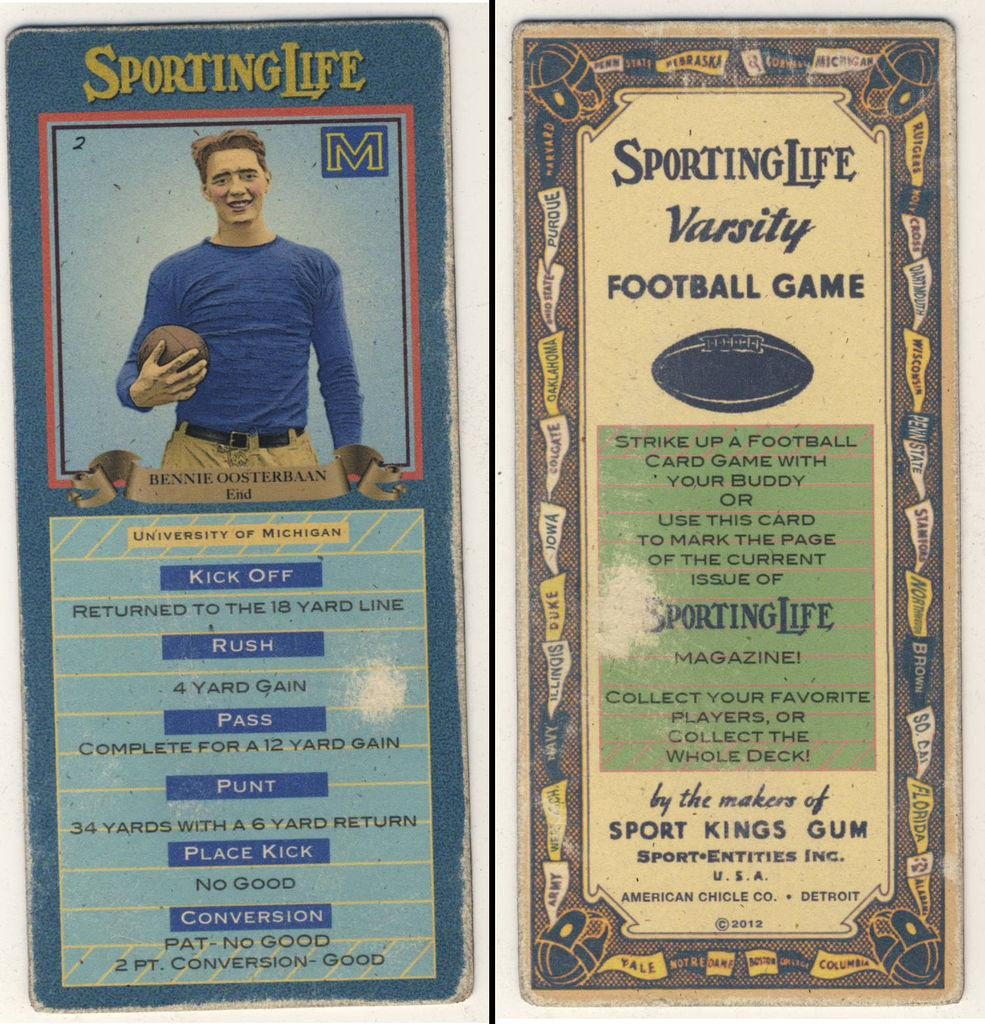What objects are present in the image? There are boards in the image. Is there any representation of a person in the image? Yes, there is a picture of a man in the image. Are there any words or letters in the image? Yes, there is text in the image. How many chickens can be seen attending the party in the image? There are no chickens or party depicted in the image; it only features boards, a picture of a man, and text. 